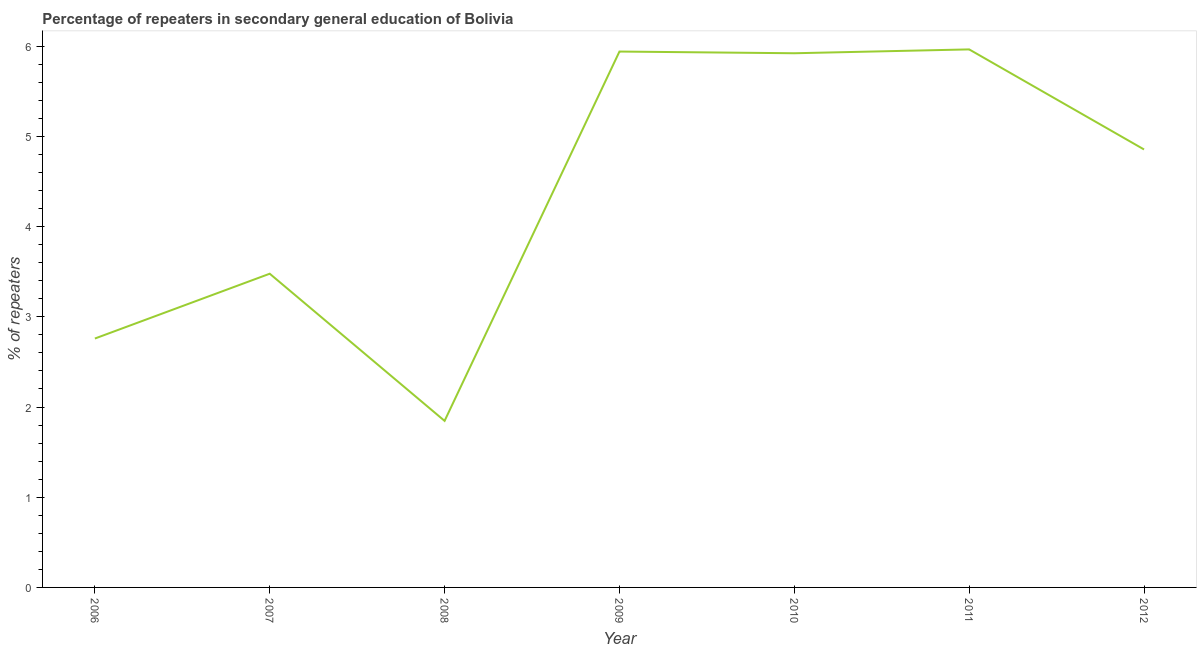What is the percentage of repeaters in 2009?
Provide a succinct answer. 5.94. Across all years, what is the maximum percentage of repeaters?
Your response must be concise. 5.96. Across all years, what is the minimum percentage of repeaters?
Your answer should be very brief. 1.85. In which year was the percentage of repeaters maximum?
Your response must be concise. 2011. What is the sum of the percentage of repeaters?
Provide a short and direct response. 30.77. What is the difference between the percentage of repeaters in 2007 and 2010?
Give a very brief answer. -2.44. What is the average percentage of repeaters per year?
Make the answer very short. 4.4. What is the median percentage of repeaters?
Provide a short and direct response. 4.86. In how many years, is the percentage of repeaters greater than 4.6 %?
Your answer should be compact. 4. Do a majority of the years between 2010 and 2006 (inclusive) have percentage of repeaters greater than 1.6 %?
Give a very brief answer. Yes. What is the ratio of the percentage of repeaters in 2007 to that in 2009?
Give a very brief answer. 0.59. Is the percentage of repeaters in 2011 less than that in 2012?
Your answer should be very brief. No. Is the difference between the percentage of repeaters in 2006 and 2010 greater than the difference between any two years?
Your answer should be very brief. No. What is the difference between the highest and the second highest percentage of repeaters?
Give a very brief answer. 0.02. Is the sum of the percentage of repeaters in 2008 and 2009 greater than the maximum percentage of repeaters across all years?
Keep it short and to the point. Yes. What is the difference between the highest and the lowest percentage of repeaters?
Offer a terse response. 4.12. In how many years, is the percentage of repeaters greater than the average percentage of repeaters taken over all years?
Offer a terse response. 4. How many lines are there?
Make the answer very short. 1. How many years are there in the graph?
Ensure brevity in your answer.  7. Are the values on the major ticks of Y-axis written in scientific E-notation?
Provide a succinct answer. No. Does the graph contain any zero values?
Make the answer very short. No. Does the graph contain grids?
Your answer should be compact. No. What is the title of the graph?
Provide a short and direct response. Percentage of repeaters in secondary general education of Bolivia. What is the label or title of the X-axis?
Your answer should be very brief. Year. What is the label or title of the Y-axis?
Offer a very short reply. % of repeaters. What is the % of repeaters of 2006?
Give a very brief answer. 2.76. What is the % of repeaters of 2007?
Provide a short and direct response. 3.48. What is the % of repeaters of 2008?
Give a very brief answer. 1.85. What is the % of repeaters of 2009?
Your response must be concise. 5.94. What is the % of repeaters in 2010?
Make the answer very short. 5.92. What is the % of repeaters of 2011?
Your answer should be very brief. 5.96. What is the % of repeaters of 2012?
Your answer should be very brief. 4.86. What is the difference between the % of repeaters in 2006 and 2007?
Make the answer very short. -0.72. What is the difference between the % of repeaters in 2006 and 2008?
Provide a short and direct response. 0.91. What is the difference between the % of repeaters in 2006 and 2009?
Provide a short and direct response. -3.18. What is the difference between the % of repeaters in 2006 and 2010?
Provide a succinct answer. -3.16. What is the difference between the % of repeaters in 2006 and 2011?
Offer a very short reply. -3.21. What is the difference between the % of repeaters in 2006 and 2012?
Provide a short and direct response. -2.1. What is the difference between the % of repeaters in 2007 and 2008?
Give a very brief answer. 1.63. What is the difference between the % of repeaters in 2007 and 2009?
Give a very brief answer. -2.46. What is the difference between the % of repeaters in 2007 and 2010?
Provide a short and direct response. -2.44. What is the difference between the % of repeaters in 2007 and 2011?
Your answer should be compact. -2.49. What is the difference between the % of repeaters in 2007 and 2012?
Give a very brief answer. -1.38. What is the difference between the % of repeaters in 2008 and 2009?
Your answer should be very brief. -4.09. What is the difference between the % of repeaters in 2008 and 2010?
Your answer should be very brief. -4.08. What is the difference between the % of repeaters in 2008 and 2011?
Your response must be concise. -4.12. What is the difference between the % of repeaters in 2008 and 2012?
Keep it short and to the point. -3.01. What is the difference between the % of repeaters in 2009 and 2010?
Offer a terse response. 0.02. What is the difference between the % of repeaters in 2009 and 2011?
Offer a very short reply. -0.02. What is the difference between the % of repeaters in 2009 and 2012?
Your answer should be compact. 1.09. What is the difference between the % of repeaters in 2010 and 2011?
Your answer should be compact. -0.04. What is the difference between the % of repeaters in 2010 and 2012?
Your answer should be very brief. 1.07. What is the difference between the % of repeaters in 2011 and 2012?
Your response must be concise. 1.11. What is the ratio of the % of repeaters in 2006 to that in 2007?
Your answer should be compact. 0.79. What is the ratio of the % of repeaters in 2006 to that in 2008?
Your response must be concise. 1.49. What is the ratio of the % of repeaters in 2006 to that in 2009?
Provide a succinct answer. 0.46. What is the ratio of the % of repeaters in 2006 to that in 2010?
Offer a very short reply. 0.47. What is the ratio of the % of repeaters in 2006 to that in 2011?
Your answer should be compact. 0.46. What is the ratio of the % of repeaters in 2006 to that in 2012?
Offer a terse response. 0.57. What is the ratio of the % of repeaters in 2007 to that in 2008?
Keep it short and to the point. 1.88. What is the ratio of the % of repeaters in 2007 to that in 2009?
Give a very brief answer. 0.58. What is the ratio of the % of repeaters in 2007 to that in 2010?
Keep it short and to the point. 0.59. What is the ratio of the % of repeaters in 2007 to that in 2011?
Your response must be concise. 0.58. What is the ratio of the % of repeaters in 2007 to that in 2012?
Your answer should be very brief. 0.72. What is the ratio of the % of repeaters in 2008 to that in 2009?
Offer a terse response. 0.31. What is the ratio of the % of repeaters in 2008 to that in 2010?
Keep it short and to the point. 0.31. What is the ratio of the % of repeaters in 2008 to that in 2011?
Provide a short and direct response. 0.31. What is the ratio of the % of repeaters in 2008 to that in 2012?
Give a very brief answer. 0.38. What is the ratio of the % of repeaters in 2009 to that in 2012?
Make the answer very short. 1.22. What is the ratio of the % of repeaters in 2010 to that in 2012?
Keep it short and to the point. 1.22. What is the ratio of the % of repeaters in 2011 to that in 2012?
Ensure brevity in your answer.  1.23. 